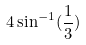<formula> <loc_0><loc_0><loc_500><loc_500>4 \sin ^ { - 1 } ( \frac { 1 } { 3 } )</formula> 